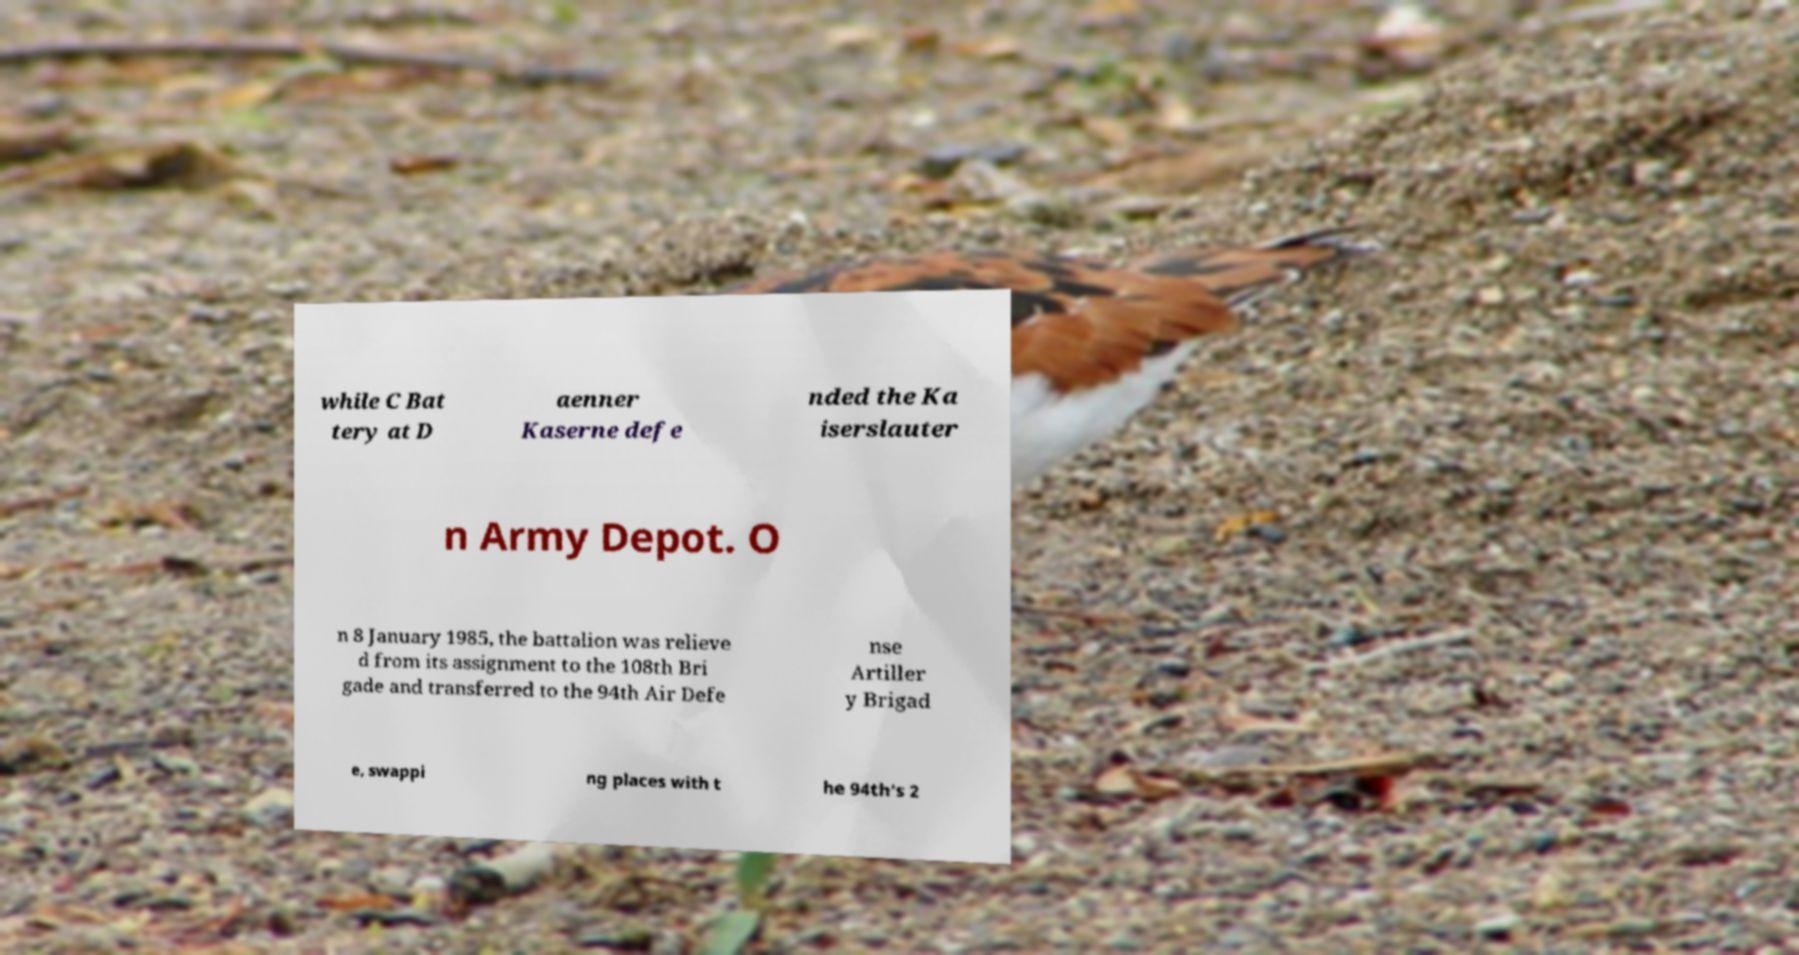Please read and relay the text visible in this image. What does it say? while C Bat tery at D aenner Kaserne defe nded the Ka iserslauter n Army Depot. O n 8 January 1985, the battalion was relieve d from its assignment to the 108th Bri gade and transferred to the 94th Air Defe nse Artiller y Brigad e, swappi ng places with t he 94th's 2 